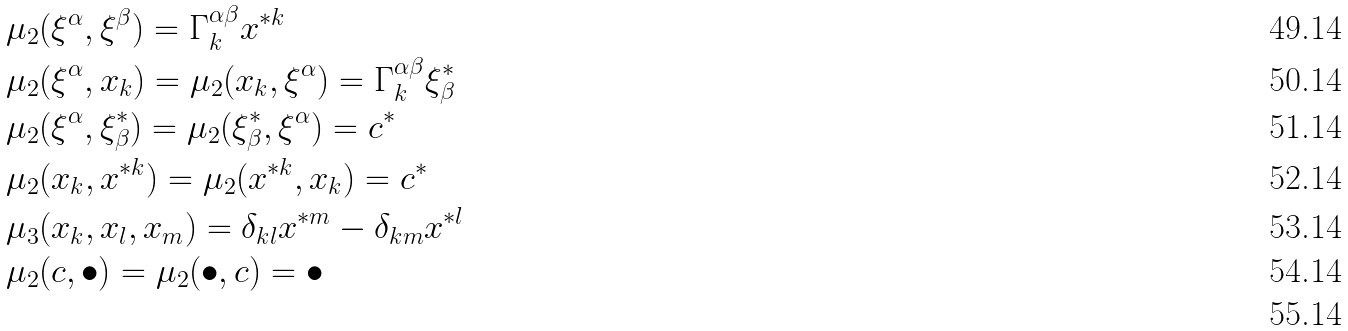<formula> <loc_0><loc_0><loc_500><loc_500>& \mu _ { 2 } ( \xi ^ { \alpha } , \xi ^ { \beta } ) = \Gamma ^ { \alpha \beta } _ { k } x ^ { \ast k } \\ & \mu _ { 2 } ( \xi ^ { \alpha } , x _ { k } ) = \mu _ { 2 } ( x _ { k } , \xi ^ { \alpha } ) = \Gamma ^ { \alpha \beta } _ { k } \xi _ { \beta } ^ { \ast } \\ & \mu _ { 2 } ( \xi ^ { \alpha } , \xi _ { \beta } ^ { \ast } ) = \mu _ { 2 } ( \xi _ { \beta } ^ { \ast } , \xi ^ { \alpha } ) = c ^ { \ast } \\ & \mu _ { 2 } ( x _ { k } , x ^ { \ast k } ) = \mu _ { 2 } ( x ^ { \ast k } , x _ { k } ) = c ^ { \ast } \\ & \mu _ { 3 } ( x _ { k } , x _ { l } , x _ { m } ) = \delta _ { k l } x ^ { \ast m } - \delta _ { k m } x ^ { \ast l } \\ & \mu _ { 2 } ( c , \bullet ) = \mu _ { 2 } ( \bullet , c ) = \bullet \\</formula> 